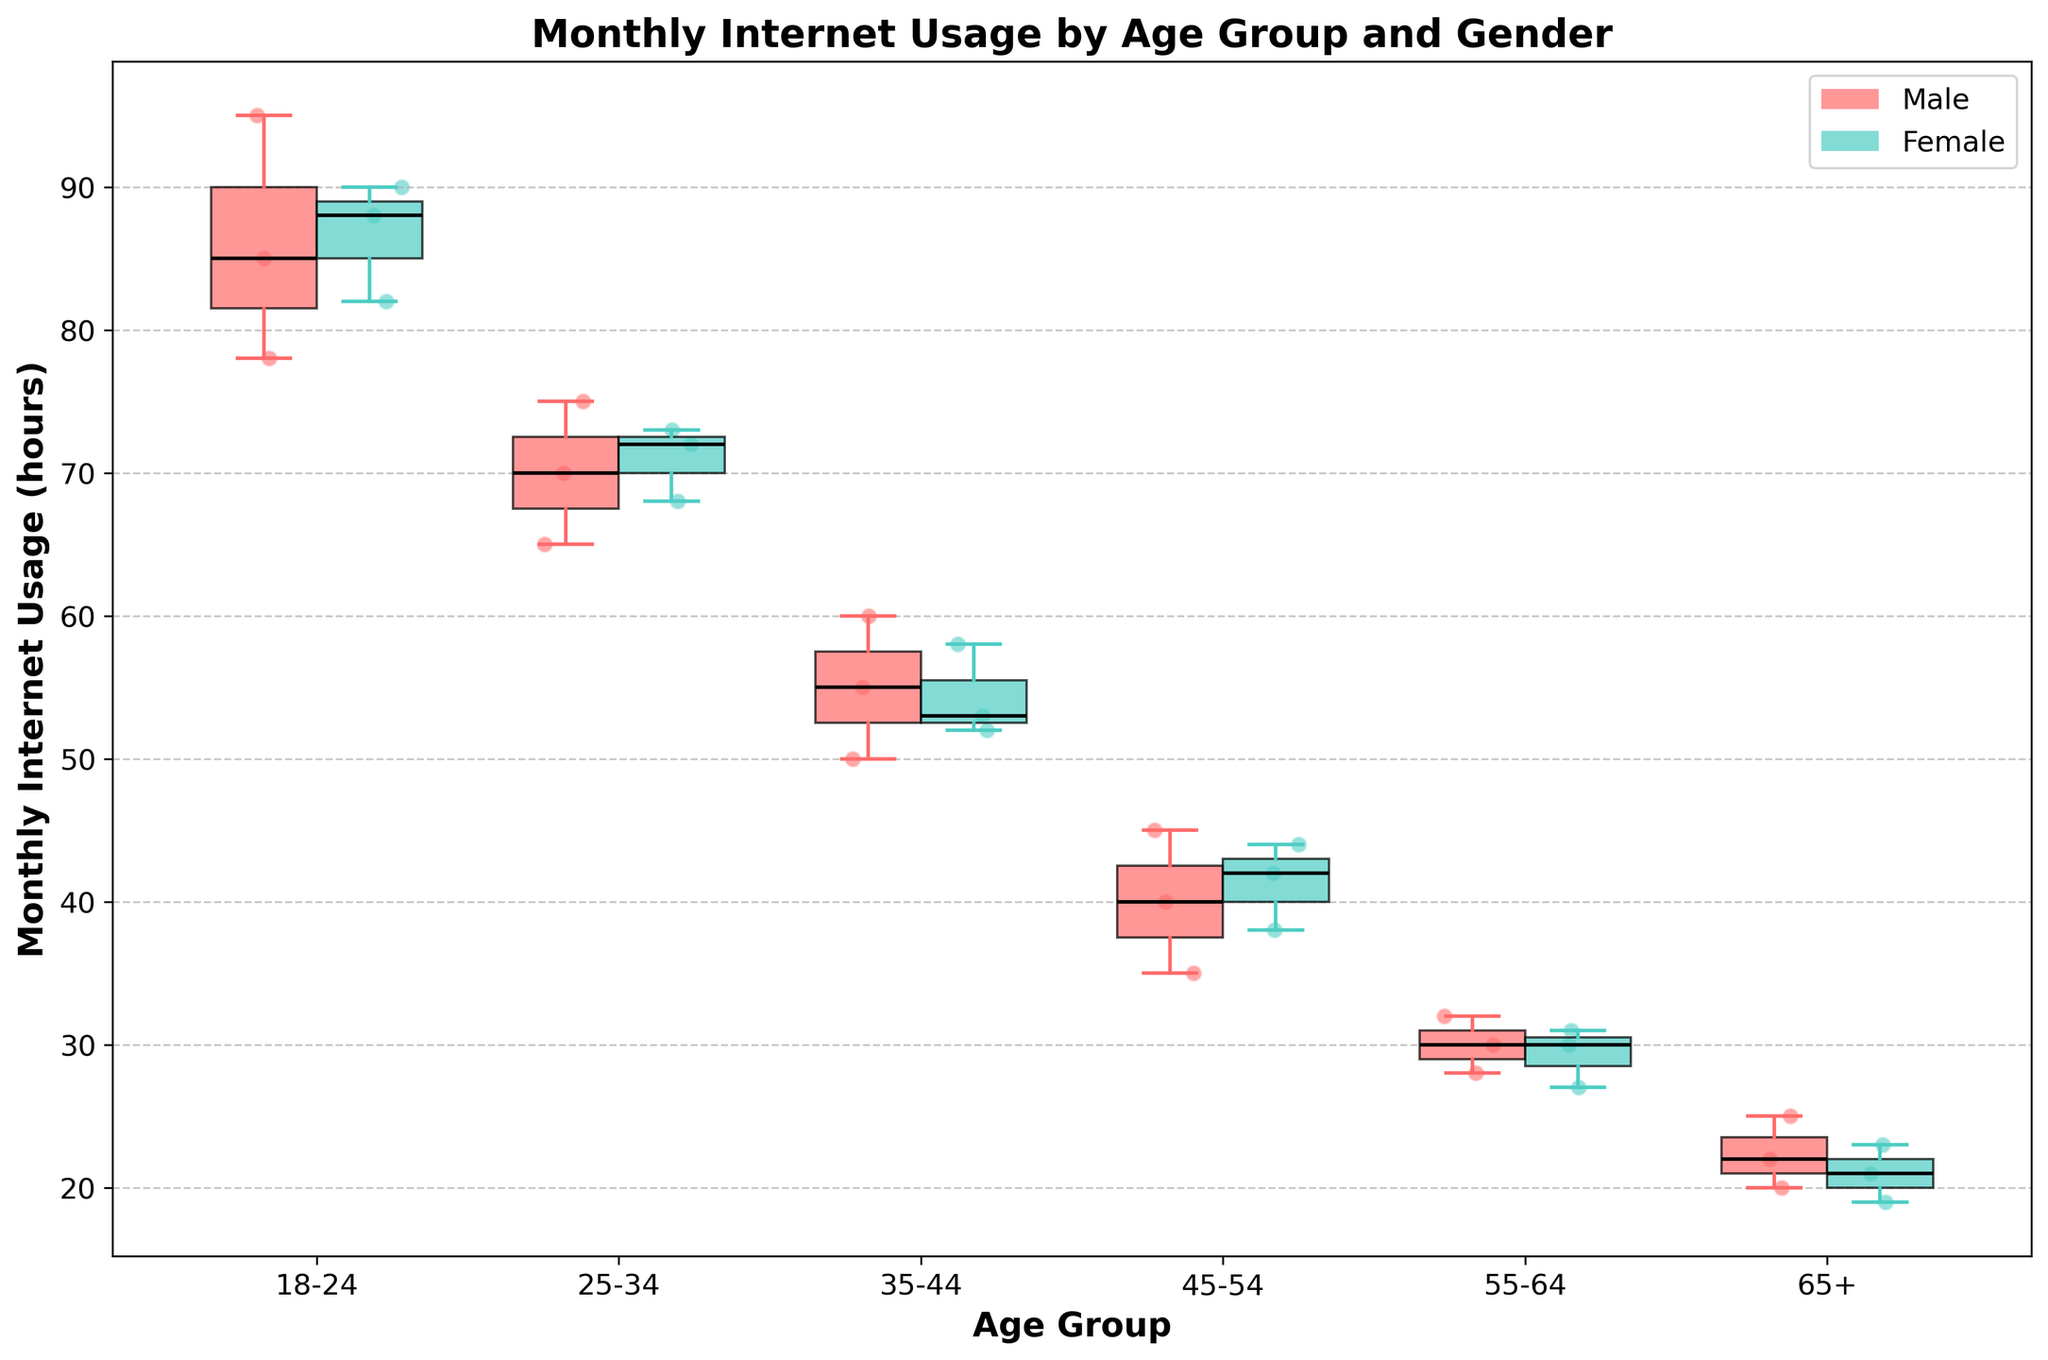what title is used for the figure? The figure's title is located at the top and provides a summary of the content depicted. In this case, it reads "Monthly Internet Usage by Age Group and Gender."
Answer: Monthly Internet Usage by Age Group and Gender How are the age groups labeled on the x-axis? The x-axis labels represent the age groups. These include: "18-24," "25-34," "35-44," "45-54," "55-64," and "65+."
Answer: 18-24, 25-34, 35-44, 45-54, 55-64, 65+ What is the median monthly internet usage for males aged 18-24? The median value is represented by the black line within the boxes. For males aged 18-24, the median is visually depicted around the middle of the box plot for this group.
Answer: 85 Which age group shows the highest variability in internet usage for females? Variability is indicated by the height of the box, representing the interquartile range. The 18-24 age group for females shows the highest variability in the figure.
Answer: 18-24 What’s the maximum monthly internet usage for males aged 25-34? The maximum value is represented by the top whisker of the box plot. For males aged 25-34, the top whisker represents the highest value observed.
Answer: 75 Compare the median monthly internet usage between males and females aged 35-44. Which gender has a higher median? The box plots allow for comparison between genders. The median for females in this age group is indicated by the median line in each respective box. The figure shows that both medians are nearly equal.
Answer: Equal For the 45-54 age group, who spends more time on the internet: males or females? By comparing the median values represented by the black lines in the boxes, the group with the higher median spends more time on the internet. The median for this age group indicates males spend more time than females.
Answer: Males Which gender has the lowest individual internet usage point in the 65+ age group? Scatter points above the box plot indicate specific observations. The lowest point for the 65+ group is visually noted at the lowest individual point.
Answer: Female What's the overall trend in median internet usage as age increases? Observing the median lines across age groups, the trend in median monthly internet usage shows a general decline as age increases.
Answer: Decline What are the colors used for the box plots representing males and females? The color of the box plots helps distinguish the gender categories. Males are represented with a reddish color, and females with a greenish color.
Answer: Red for males, green for females 